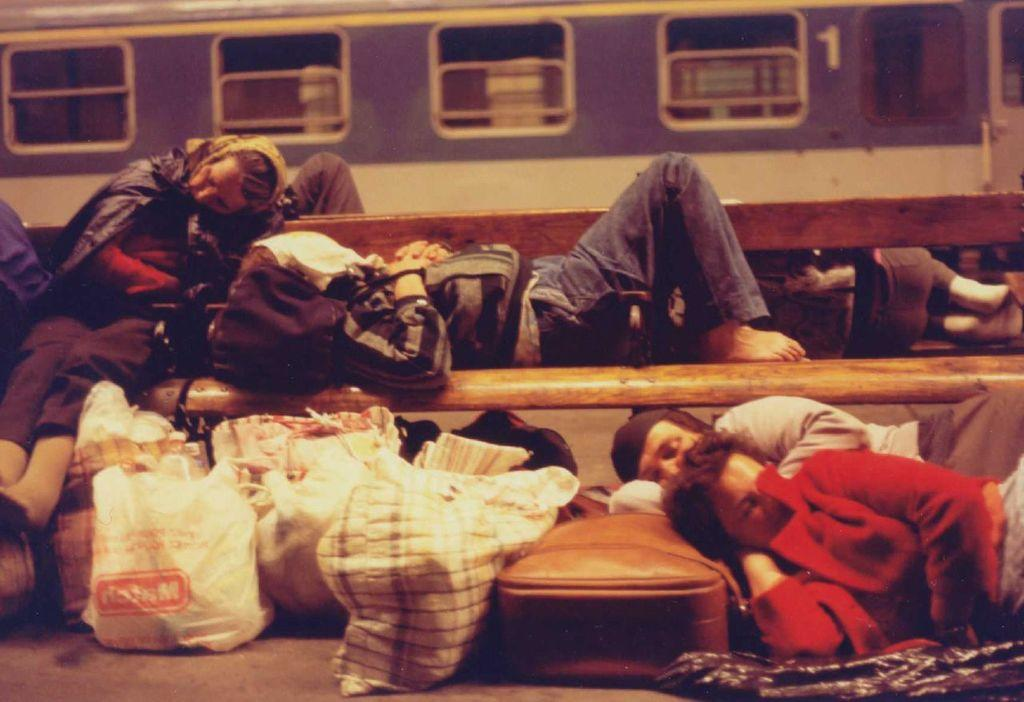What are the people in the image doing? The people in the image are sleeping. What is the main object in the image that the people are using? There is a bench in the image that the people are sleeping on. What items can be seen near the people in the image? There are bags in the image. What can be seen in the background of the image? There is a train and windows in the background of the image. How many snails can be seen crawling on the bench in the image? There are no snails visible in the image; it only shows people sleeping on a bench. What type of lipstick is the person wearing in the image? There are no people wearing lipstick in the image; it only shows people sleeping on a bench. 